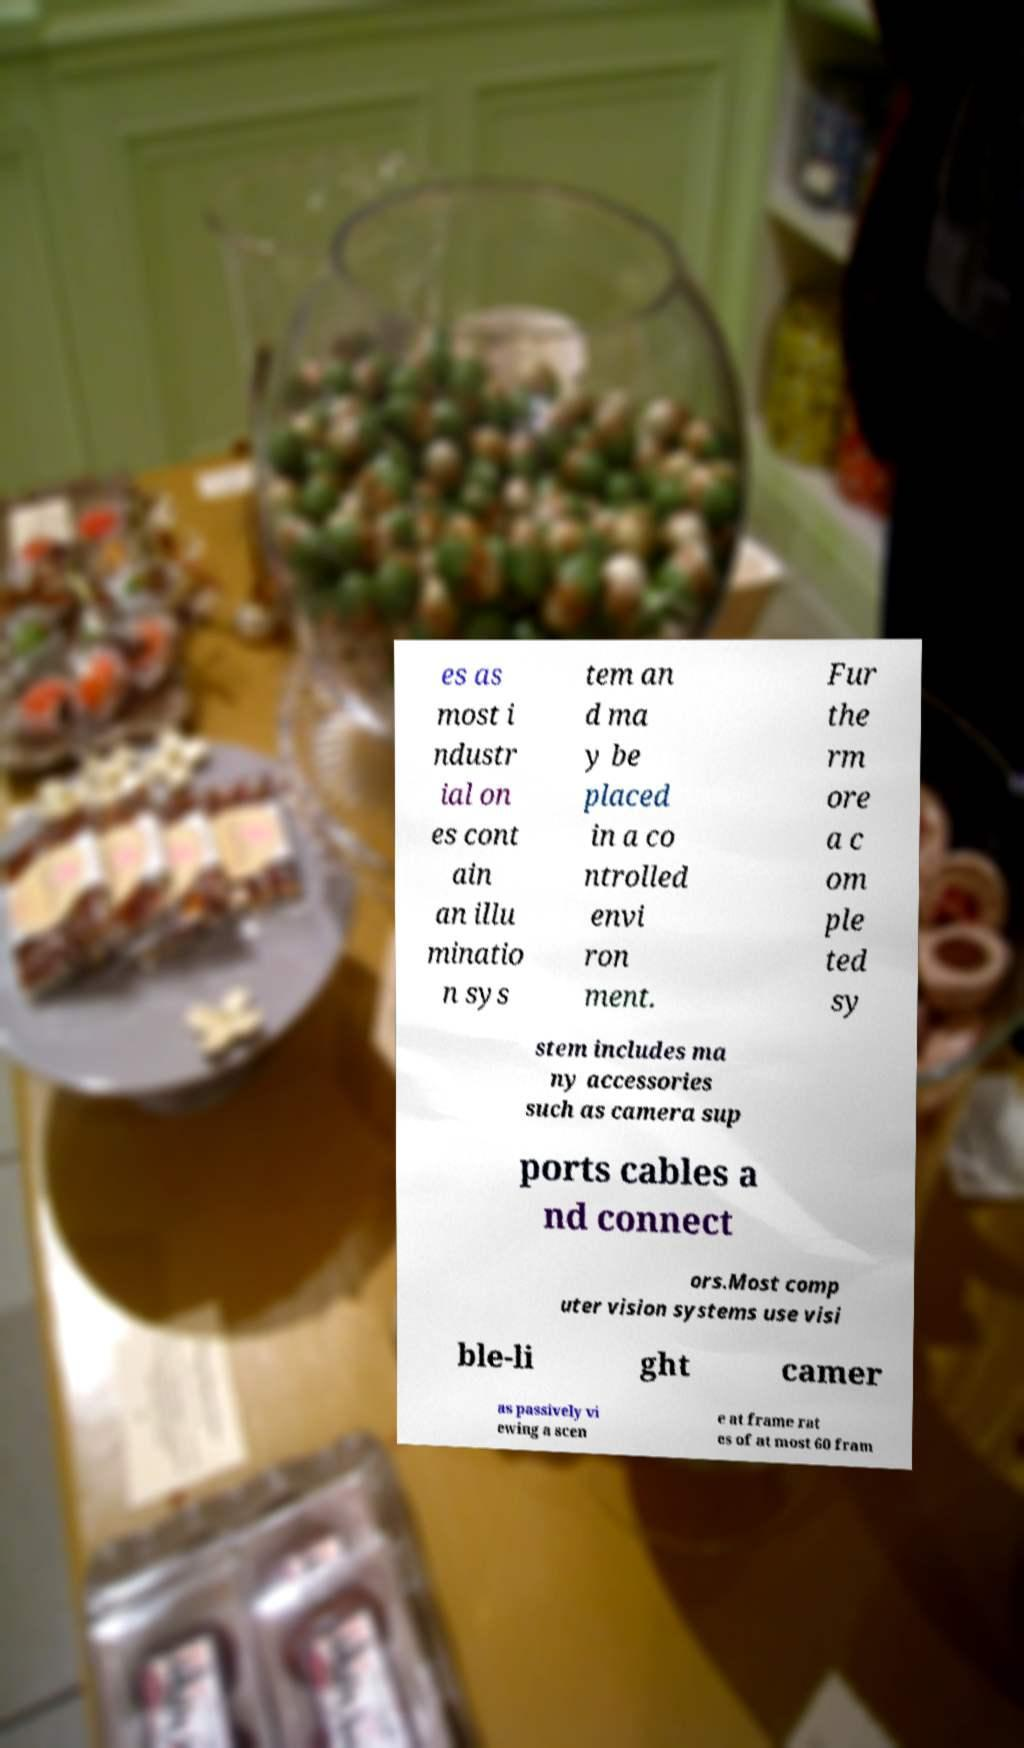Please read and relay the text visible in this image. What does it say? es as most i ndustr ial on es cont ain an illu minatio n sys tem an d ma y be placed in a co ntrolled envi ron ment. Fur the rm ore a c om ple ted sy stem includes ma ny accessories such as camera sup ports cables a nd connect ors.Most comp uter vision systems use visi ble-li ght camer as passively vi ewing a scen e at frame rat es of at most 60 fram 